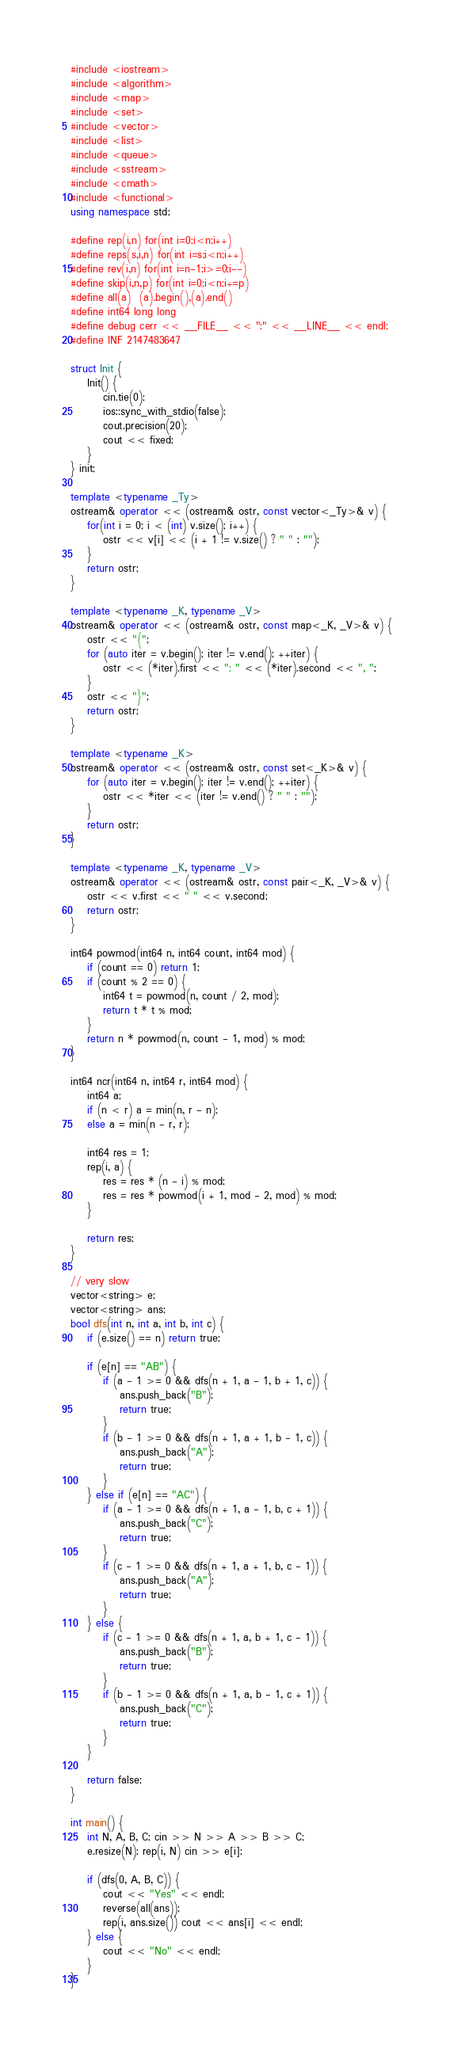<code> <loc_0><loc_0><loc_500><loc_500><_C++_>#include <iostream>
#include <algorithm>
#include <map>
#include <set>
#include <vector>
#include <list>
#include <queue>
#include <sstream>
#include <cmath>
#include <functional>
using namespace std;

#define rep(i,n) for(int i=0;i<n;i++)
#define reps(s,i,n) for(int i=s;i<n;i++)
#define rev(i,n) for(int i=n-1;i>=0;i--)
#define skip(i,n,p) for(int i=0;i<n;i+=p)
#define all(a)  (a).begin(),(a).end()
#define int64 long long
#define debug cerr << __FILE__ << ":" << __LINE__ << endl;
#define INF 2147483647

struct Init {
    Init() {
        cin.tie(0);
        ios::sync_with_stdio(false);
        cout.precision(20);
        cout << fixed;
    }
} init;

template <typename _Ty>
ostream& operator << (ostream& ostr, const vector<_Ty>& v) {
    for(int i = 0; i < (int) v.size(); i++) {
        ostr << v[i] << (i + 1 != v.size() ? " " : "");
    }
    return ostr;
}

template <typename _K, typename _V>
ostream& operator << (ostream& ostr, const map<_K, _V>& v) {
    ostr << "{";
    for (auto iter = v.begin(); iter != v.end(); ++iter) {
        ostr << (*iter).first << ": " << (*iter).second << ", ";
    }
    ostr << "}";
    return ostr;
}

template <typename _K>
ostream& operator << (ostream& ostr, const set<_K>& v) {
    for (auto iter = v.begin(); iter != v.end(); ++iter) {
        ostr << *iter << (iter != v.end() ? " " : "");
    }
    return ostr;
}

template <typename _K, typename _V>
ostream& operator << (ostream& ostr, const pair<_K, _V>& v) {
    ostr << v.first << " " << v.second;
    return ostr;
}

int64 powmod(int64 n, int64 count, int64 mod) {
    if (count == 0) return 1;
    if (count % 2 == 0) {
        int64 t = powmod(n, count / 2, mod);
        return t * t % mod;
    }
    return n * powmod(n, count - 1, mod) % mod;
}

int64 ncr(int64 n, int64 r, int64 mod) {
    int64 a;
    if (n < r) a = min(n, r - n);
    else a = min(n - r, r);

    int64 res = 1;
    rep(i, a) {
        res = res * (n - i) % mod;
        res = res * powmod(i + 1, mod - 2, mod) % mod;
    }

    return res;
}

// very slow
vector<string> e;
vector<string> ans;
bool dfs(int n, int a, int b, int c) {
    if (e.size() == n) return true;

    if (e[n] == "AB") {
        if (a - 1 >= 0 && dfs(n + 1, a - 1, b + 1, c)) {
            ans.push_back("B");
            return true;
        }
        if (b - 1 >= 0 && dfs(n + 1, a + 1, b - 1, c)) {
            ans.push_back("A");
            return true;
        }
    } else if (e[n] == "AC") {
        if (a - 1 >= 0 && dfs(n + 1, a - 1, b, c + 1)) {
            ans.push_back("C");
            return true;
        }
        if (c - 1 >= 0 && dfs(n + 1, a + 1, b, c - 1)) {
            ans.push_back("A");
            return true;
        }
    } else {
        if (c - 1 >= 0 && dfs(n + 1, a, b + 1, c - 1)) {
            ans.push_back("B");
            return true;
        }
        if (b - 1 >= 0 && dfs(n + 1, a, b - 1, c + 1)) {
            ans.push_back("C");
            return true;
        }
    }

    return false;
}

int main() {
    int N, A, B, C; cin >> N >> A >> B >> C;
    e.resize(N); rep(i, N) cin >> e[i];

    if (dfs(0, A, B, C)) {
        cout << "Yes" << endl;
        reverse(all(ans));
        rep(i, ans.size()) cout << ans[i] << endl;
    } else {
        cout << "No" << endl;
    }
}
</code> 